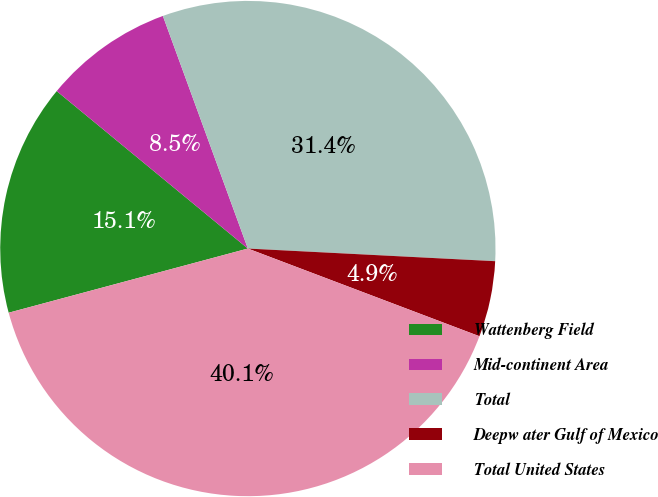<chart> <loc_0><loc_0><loc_500><loc_500><pie_chart><fcel>Wattenberg Field<fcel>Mid-continent Area<fcel>Total<fcel>Deepw ater Gulf of Mexico<fcel>Total United States<nl><fcel>15.14%<fcel>8.46%<fcel>31.39%<fcel>4.95%<fcel>40.07%<nl></chart> 